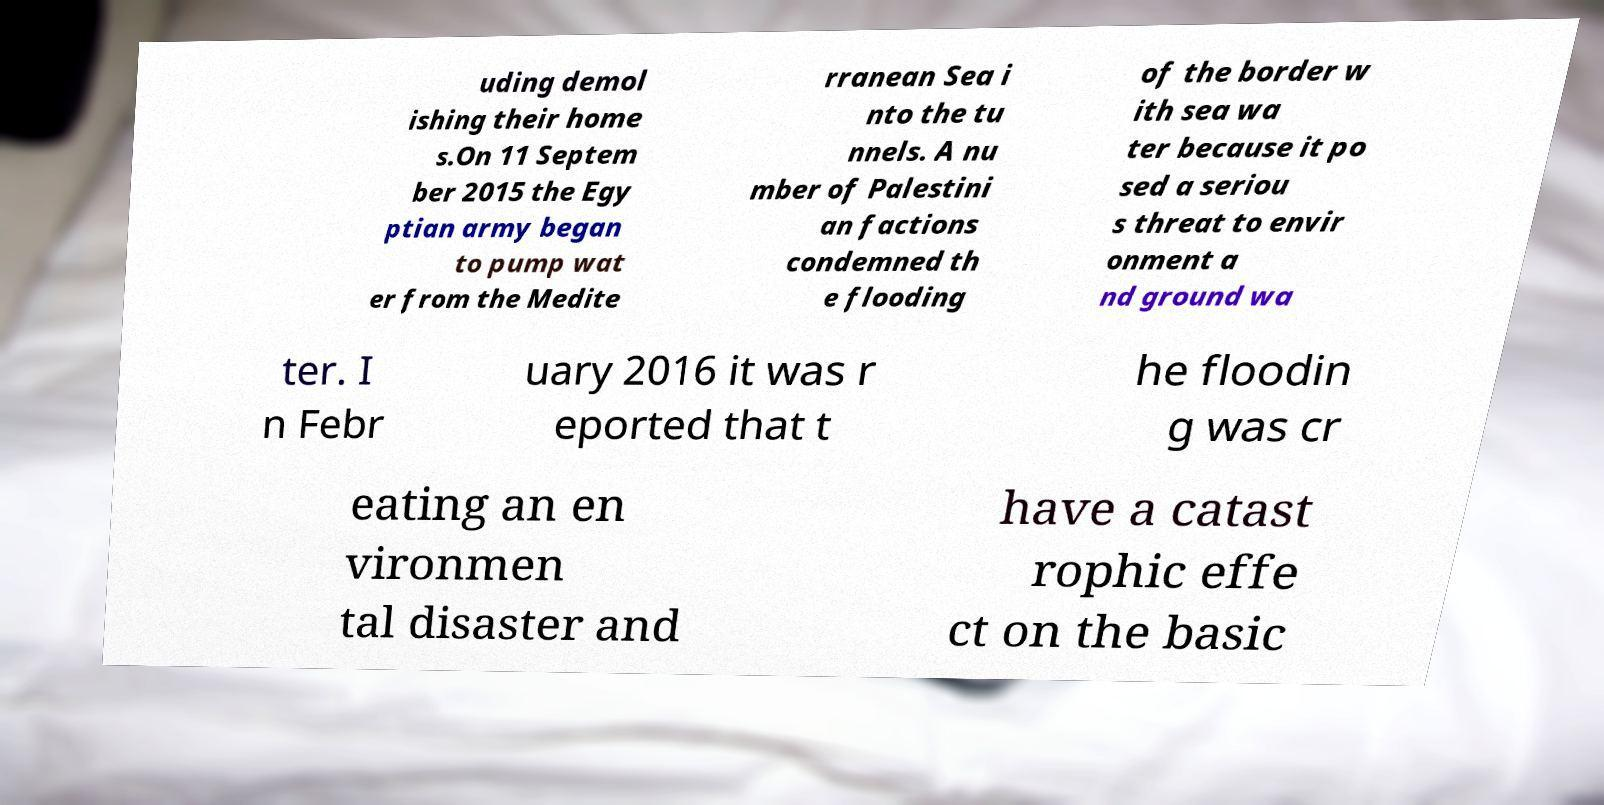Could you assist in decoding the text presented in this image and type it out clearly? uding demol ishing their home s.On 11 Septem ber 2015 the Egy ptian army began to pump wat er from the Medite rranean Sea i nto the tu nnels. A nu mber of Palestini an factions condemned th e flooding of the border w ith sea wa ter because it po sed a seriou s threat to envir onment a nd ground wa ter. I n Febr uary 2016 it was r eported that t he floodin g was cr eating an en vironmen tal disaster and have a catast rophic effe ct on the basic 